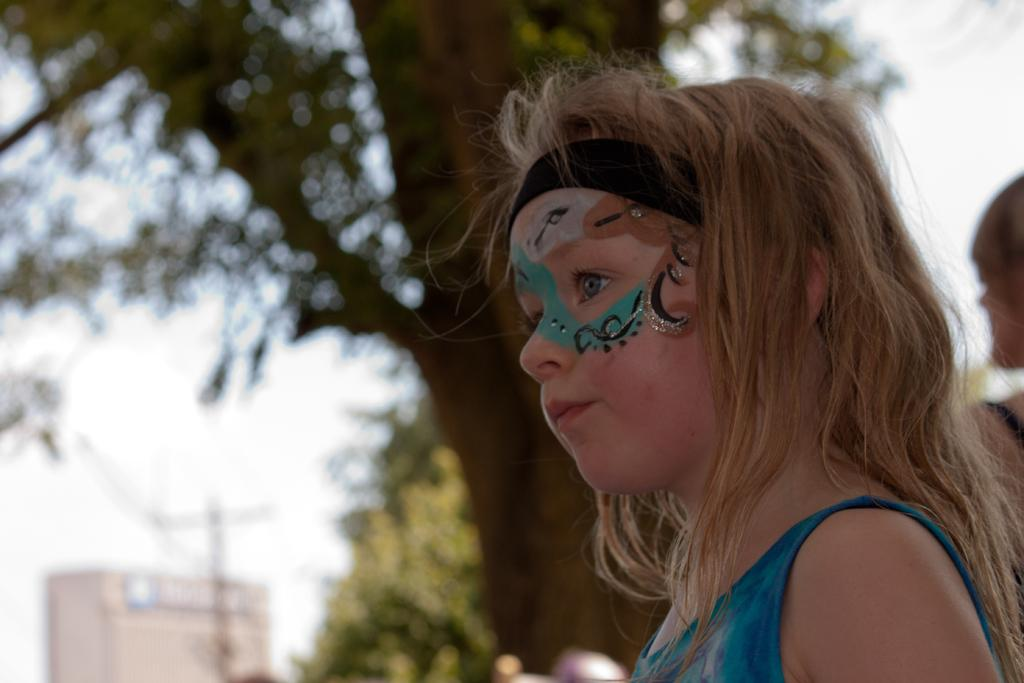Who is present in the image? There is a girl in the image. What is unique about the girl's appearance? The girl has a painting on her face. What type of natural environment can be seen in the image? There are trees in the image. Are there any man-made structures visible? Yes, there is at least one building in the image. What is visible in the background of the image? The sky is visible in the background of the image. How many trucks are parked in the garden in the image? There are no trucks or gardens present in the image. 